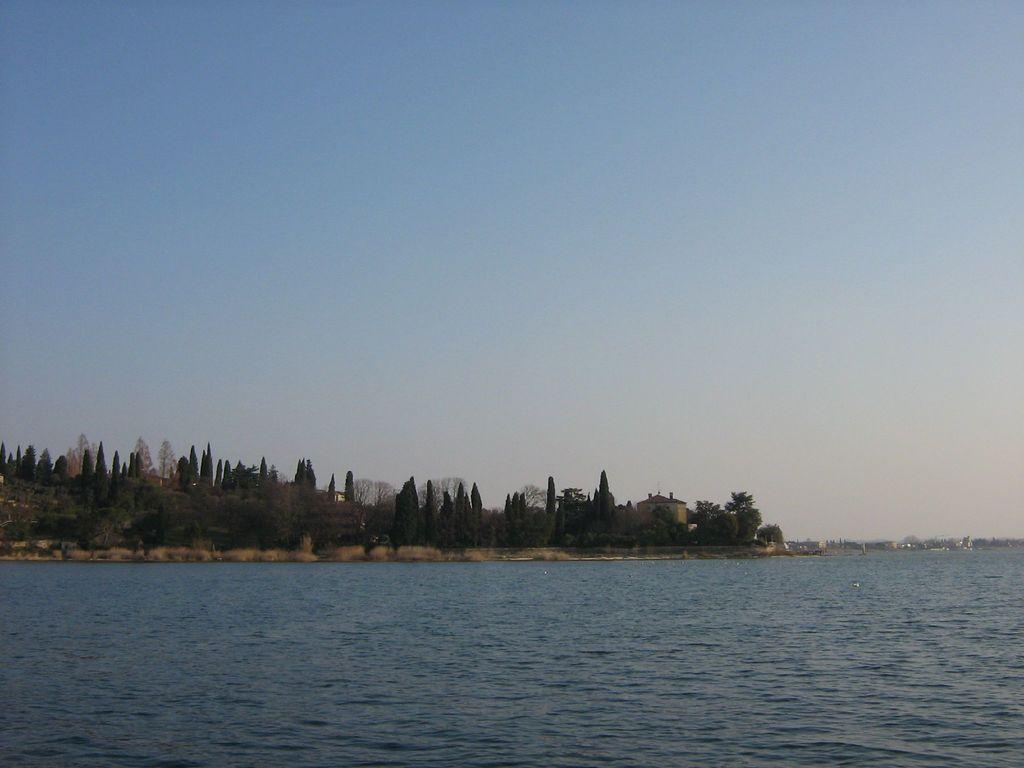What is visible in the image that is not a solid structure? There is water visible in the image. What type of natural vegetation can be seen in the image? There are trees in the image. What type of man-made structures are present in the image? There are buildings in the image. What is visible above the structures and vegetation in the image? The sky is visible in the image. Can you describe the snake's temper in the image? There is no snake present in the image, so it is not possible to describe its temper. 